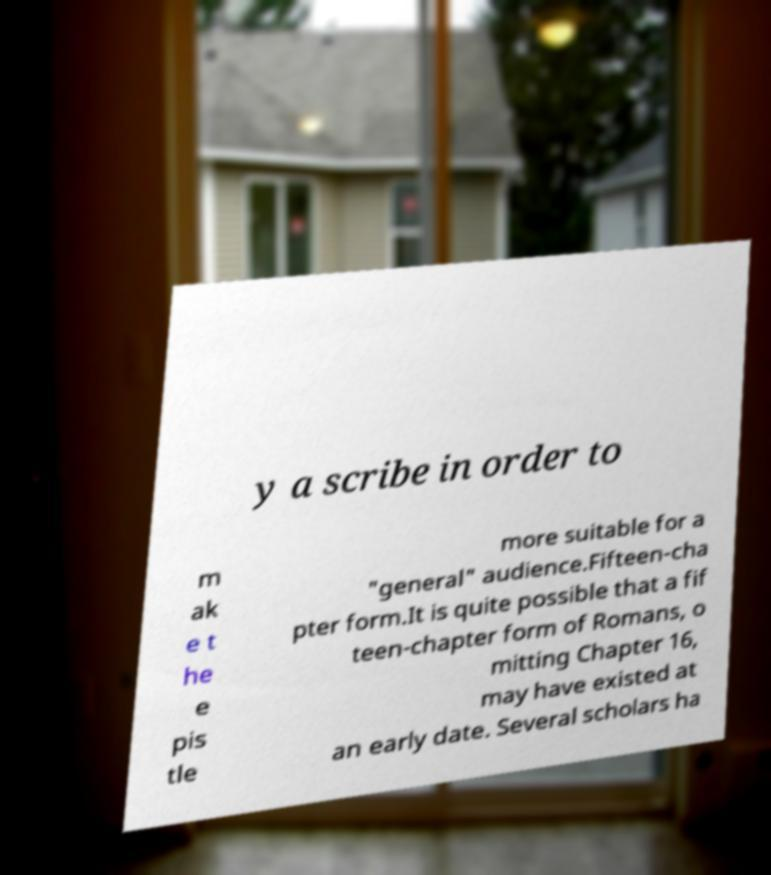Could you extract and type out the text from this image? y a scribe in order to m ak e t he e pis tle more suitable for a "general" audience.Fifteen-cha pter form.It is quite possible that a fif teen-chapter form of Romans, o mitting Chapter 16, may have existed at an early date. Several scholars ha 